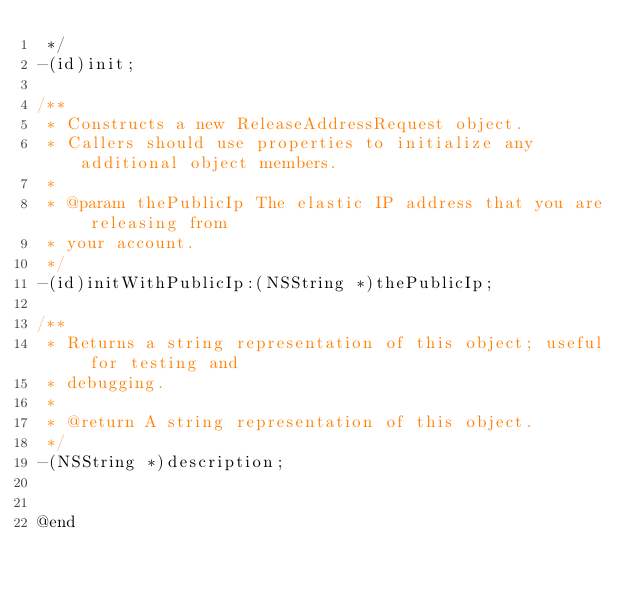<code> <loc_0><loc_0><loc_500><loc_500><_C_> */
-(id)init;

/**
 * Constructs a new ReleaseAddressRequest object.
 * Callers should use properties to initialize any additional object members.
 *
 * @param thePublicIp The elastic IP address that you are releasing from
 * your account.
 */
-(id)initWithPublicIp:(NSString *)thePublicIp;

/**
 * Returns a string representation of this object; useful for testing and
 * debugging.
 *
 * @return A string representation of this object.
 */
-(NSString *)description;


@end
</code> 